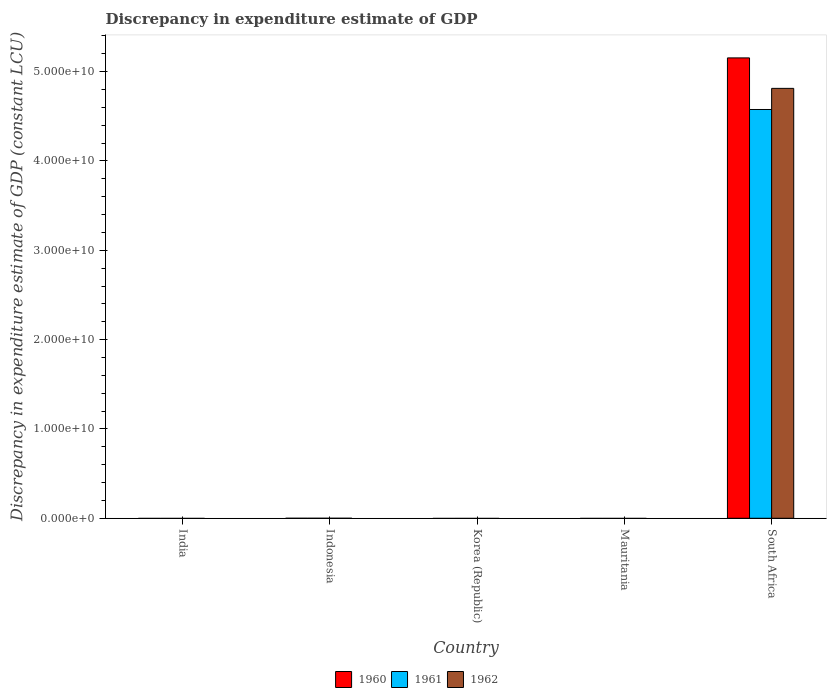How many different coloured bars are there?
Keep it short and to the point. 3. Are the number of bars per tick equal to the number of legend labels?
Ensure brevity in your answer.  No. Are the number of bars on each tick of the X-axis equal?
Your response must be concise. No. Across all countries, what is the maximum discrepancy in expenditure estimate of GDP in 1962?
Provide a short and direct response. 4.81e+1. In which country was the discrepancy in expenditure estimate of GDP in 1962 maximum?
Provide a succinct answer. South Africa. What is the total discrepancy in expenditure estimate of GDP in 1962 in the graph?
Offer a terse response. 4.81e+1. What is the average discrepancy in expenditure estimate of GDP in 1962 per country?
Offer a very short reply. 9.62e+09. What is the difference between the discrepancy in expenditure estimate of GDP of/in 1962 and discrepancy in expenditure estimate of GDP of/in 1960 in South Africa?
Make the answer very short. -3.41e+09. What is the difference between the highest and the lowest discrepancy in expenditure estimate of GDP in 1960?
Offer a very short reply. 5.15e+1. Is it the case that in every country, the sum of the discrepancy in expenditure estimate of GDP in 1962 and discrepancy in expenditure estimate of GDP in 1960 is greater than the discrepancy in expenditure estimate of GDP in 1961?
Make the answer very short. No. How many countries are there in the graph?
Offer a terse response. 5. Does the graph contain grids?
Provide a succinct answer. No. Where does the legend appear in the graph?
Give a very brief answer. Bottom center. How many legend labels are there?
Give a very brief answer. 3. What is the title of the graph?
Your answer should be very brief. Discrepancy in expenditure estimate of GDP. What is the label or title of the Y-axis?
Ensure brevity in your answer.  Discrepancy in expenditure estimate of GDP (constant LCU). What is the Discrepancy in expenditure estimate of GDP (constant LCU) in 1962 in India?
Keep it short and to the point. 0. What is the Discrepancy in expenditure estimate of GDP (constant LCU) in 1961 in Indonesia?
Make the answer very short. 0. What is the Discrepancy in expenditure estimate of GDP (constant LCU) in 1960 in Mauritania?
Your answer should be very brief. 0. What is the Discrepancy in expenditure estimate of GDP (constant LCU) in 1962 in Mauritania?
Offer a very short reply. 0. What is the Discrepancy in expenditure estimate of GDP (constant LCU) in 1960 in South Africa?
Make the answer very short. 5.15e+1. What is the Discrepancy in expenditure estimate of GDP (constant LCU) of 1961 in South Africa?
Provide a succinct answer. 4.58e+1. What is the Discrepancy in expenditure estimate of GDP (constant LCU) in 1962 in South Africa?
Your answer should be very brief. 4.81e+1. Across all countries, what is the maximum Discrepancy in expenditure estimate of GDP (constant LCU) in 1960?
Make the answer very short. 5.15e+1. Across all countries, what is the maximum Discrepancy in expenditure estimate of GDP (constant LCU) in 1961?
Provide a succinct answer. 4.58e+1. Across all countries, what is the maximum Discrepancy in expenditure estimate of GDP (constant LCU) in 1962?
Your answer should be compact. 4.81e+1. Across all countries, what is the minimum Discrepancy in expenditure estimate of GDP (constant LCU) in 1960?
Your answer should be compact. 0. Across all countries, what is the minimum Discrepancy in expenditure estimate of GDP (constant LCU) of 1961?
Ensure brevity in your answer.  0. What is the total Discrepancy in expenditure estimate of GDP (constant LCU) in 1960 in the graph?
Offer a very short reply. 5.15e+1. What is the total Discrepancy in expenditure estimate of GDP (constant LCU) of 1961 in the graph?
Provide a succinct answer. 4.58e+1. What is the total Discrepancy in expenditure estimate of GDP (constant LCU) in 1962 in the graph?
Provide a succinct answer. 4.81e+1. What is the average Discrepancy in expenditure estimate of GDP (constant LCU) in 1960 per country?
Keep it short and to the point. 1.03e+1. What is the average Discrepancy in expenditure estimate of GDP (constant LCU) of 1961 per country?
Provide a short and direct response. 9.15e+09. What is the average Discrepancy in expenditure estimate of GDP (constant LCU) of 1962 per country?
Provide a short and direct response. 9.62e+09. What is the difference between the Discrepancy in expenditure estimate of GDP (constant LCU) in 1960 and Discrepancy in expenditure estimate of GDP (constant LCU) in 1961 in South Africa?
Provide a succinct answer. 5.78e+09. What is the difference between the Discrepancy in expenditure estimate of GDP (constant LCU) in 1960 and Discrepancy in expenditure estimate of GDP (constant LCU) in 1962 in South Africa?
Ensure brevity in your answer.  3.41e+09. What is the difference between the Discrepancy in expenditure estimate of GDP (constant LCU) in 1961 and Discrepancy in expenditure estimate of GDP (constant LCU) in 1962 in South Africa?
Keep it short and to the point. -2.37e+09. What is the difference between the highest and the lowest Discrepancy in expenditure estimate of GDP (constant LCU) of 1960?
Offer a very short reply. 5.15e+1. What is the difference between the highest and the lowest Discrepancy in expenditure estimate of GDP (constant LCU) of 1961?
Give a very brief answer. 4.58e+1. What is the difference between the highest and the lowest Discrepancy in expenditure estimate of GDP (constant LCU) of 1962?
Make the answer very short. 4.81e+1. 